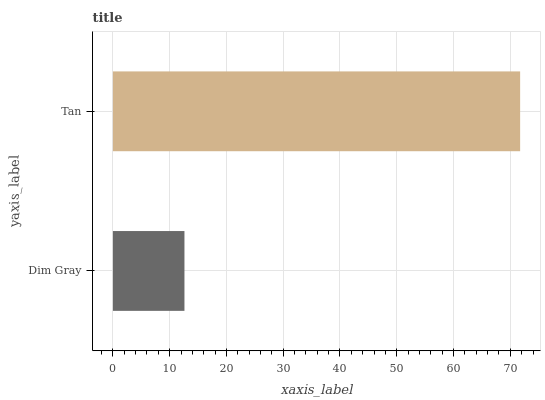Is Dim Gray the minimum?
Answer yes or no. Yes. Is Tan the maximum?
Answer yes or no. Yes. Is Tan the minimum?
Answer yes or no. No. Is Tan greater than Dim Gray?
Answer yes or no. Yes. Is Dim Gray less than Tan?
Answer yes or no. Yes. Is Dim Gray greater than Tan?
Answer yes or no. No. Is Tan less than Dim Gray?
Answer yes or no. No. Is Tan the high median?
Answer yes or no. Yes. Is Dim Gray the low median?
Answer yes or no. Yes. Is Dim Gray the high median?
Answer yes or no. No. Is Tan the low median?
Answer yes or no. No. 